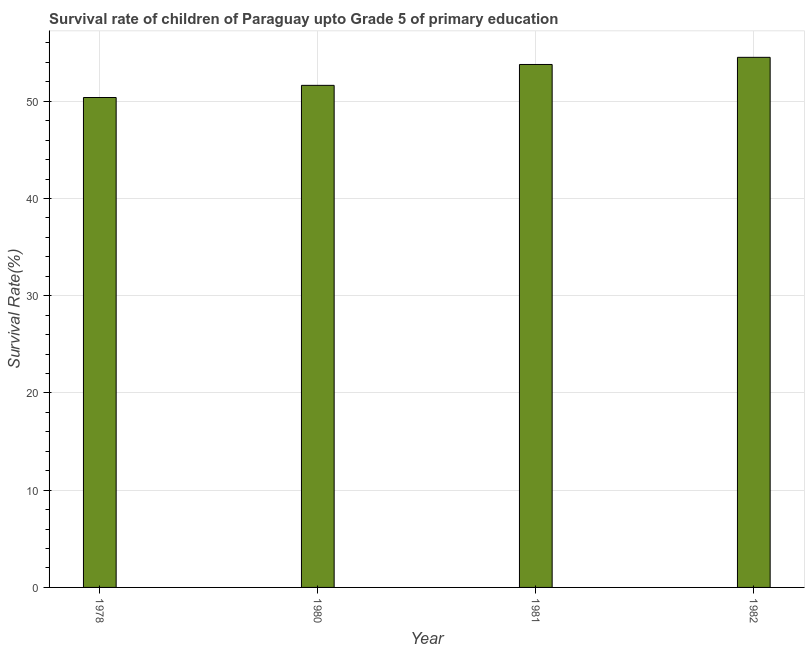Does the graph contain any zero values?
Your answer should be compact. No. What is the title of the graph?
Give a very brief answer. Survival rate of children of Paraguay upto Grade 5 of primary education. What is the label or title of the Y-axis?
Provide a succinct answer. Survival Rate(%). What is the survival rate in 1982?
Your answer should be very brief. 54.52. Across all years, what is the maximum survival rate?
Make the answer very short. 54.52. Across all years, what is the minimum survival rate?
Keep it short and to the point. 50.38. In which year was the survival rate minimum?
Provide a succinct answer. 1978. What is the sum of the survival rate?
Your answer should be very brief. 210.32. What is the difference between the survival rate in 1980 and 1981?
Offer a terse response. -2.15. What is the average survival rate per year?
Give a very brief answer. 52.58. What is the median survival rate?
Your response must be concise. 52.71. In how many years, is the survival rate greater than 32 %?
Your answer should be compact. 4. Do a majority of the years between 1980 and 1981 (inclusive) have survival rate greater than 20 %?
Your response must be concise. Yes. What is the ratio of the survival rate in 1980 to that in 1982?
Make the answer very short. 0.95. Is the difference between the survival rate in 1981 and 1982 greater than the difference between any two years?
Give a very brief answer. No. What is the difference between the highest and the second highest survival rate?
Make the answer very short. 0.73. Is the sum of the survival rate in 1978 and 1982 greater than the maximum survival rate across all years?
Provide a short and direct response. Yes. What is the difference between the highest and the lowest survival rate?
Provide a short and direct response. 4.13. In how many years, is the survival rate greater than the average survival rate taken over all years?
Offer a very short reply. 2. Are all the bars in the graph horizontal?
Make the answer very short. No. What is the Survival Rate(%) of 1978?
Ensure brevity in your answer.  50.38. What is the Survival Rate(%) in 1980?
Offer a very short reply. 51.64. What is the Survival Rate(%) of 1981?
Give a very brief answer. 53.78. What is the Survival Rate(%) in 1982?
Ensure brevity in your answer.  54.52. What is the difference between the Survival Rate(%) in 1978 and 1980?
Provide a short and direct response. -1.25. What is the difference between the Survival Rate(%) in 1978 and 1981?
Offer a terse response. -3.4. What is the difference between the Survival Rate(%) in 1978 and 1982?
Offer a very short reply. -4.13. What is the difference between the Survival Rate(%) in 1980 and 1981?
Your answer should be very brief. -2.15. What is the difference between the Survival Rate(%) in 1980 and 1982?
Your answer should be compact. -2.88. What is the difference between the Survival Rate(%) in 1981 and 1982?
Make the answer very short. -0.73. What is the ratio of the Survival Rate(%) in 1978 to that in 1981?
Provide a succinct answer. 0.94. What is the ratio of the Survival Rate(%) in 1978 to that in 1982?
Your answer should be very brief. 0.92. What is the ratio of the Survival Rate(%) in 1980 to that in 1981?
Offer a very short reply. 0.96. What is the ratio of the Survival Rate(%) in 1980 to that in 1982?
Offer a terse response. 0.95. What is the ratio of the Survival Rate(%) in 1981 to that in 1982?
Offer a very short reply. 0.99. 